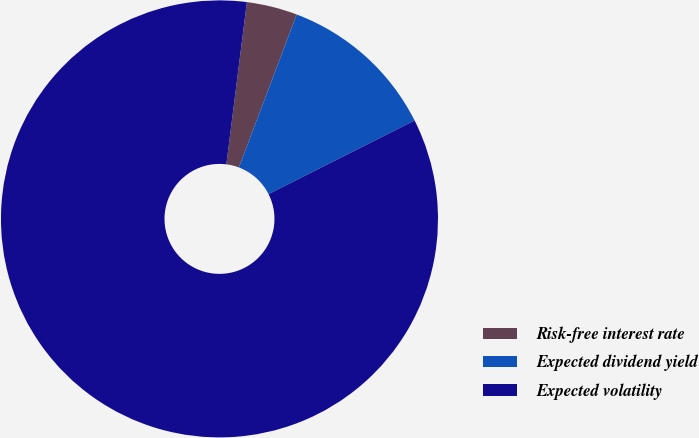<chart> <loc_0><loc_0><loc_500><loc_500><pie_chart><fcel>Risk-free interest rate<fcel>Expected dividend yield<fcel>Expected volatility<nl><fcel>3.75%<fcel>11.82%<fcel>84.44%<nl></chart> 